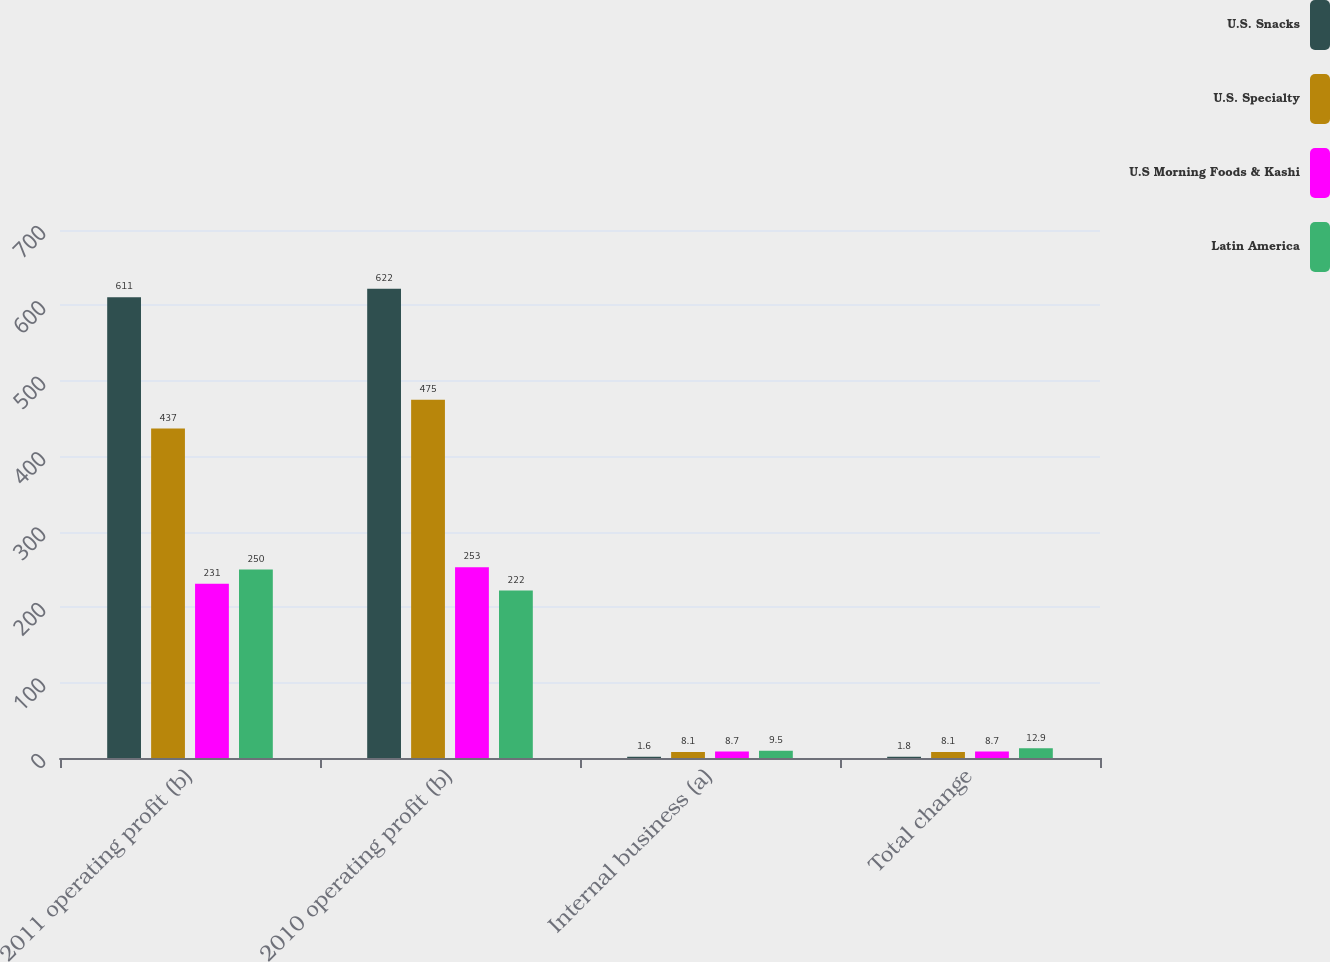Convert chart to OTSL. <chart><loc_0><loc_0><loc_500><loc_500><stacked_bar_chart><ecel><fcel>2011 operating profit (b)<fcel>2010 operating profit (b)<fcel>Internal business (a)<fcel>Total change<nl><fcel>U.S. Snacks<fcel>611<fcel>622<fcel>1.6<fcel>1.8<nl><fcel>U.S. Specialty<fcel>437<fcel>475<fcel>8.1<fcel>8.1<nl><fcel>U.S Morning Foods & Kashi<fcel>231<fcel>253<fcel>8.7<fcel>8.7<nl><fcel>Latin America<fcel>250<fcel>222<fcel>9.5<fcel>12.9<nl></chart> 